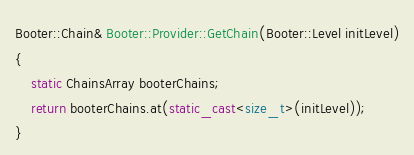<code> <loc_0><loc_0><loc_500><loc_500><_C++_>Booter::Chain& Booter::Provider::GetChain(Booter::Level initLevel)
{
    static ChainsArray booterChains;
    return booterChains.at(static_cast<size_t>(initLevel));
}
</code> 